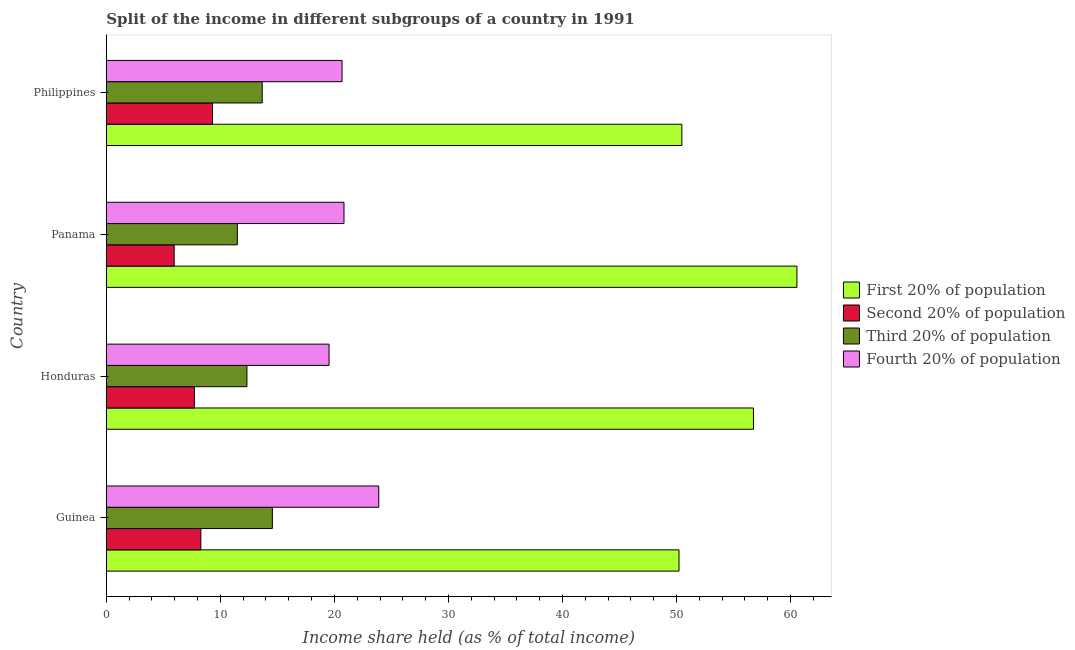Are the number of bars on each tick of the Y-axis equal?
Make the answer very short. Yes. How many bars are there on the 1st tick from the top?
Your answer should be very brief. 4. What is the share of the income held by first 20% of the population in Panama?
Ensure brevity in your answer.  60.56. Across all countries, what is the maximum share of the income held by second 20% of the population?
Your answer should be compact. 9.31. Across all countries, what is the minimum share of the income held by third 20% of the population?
Give a very brief answer. 11.49. In which country was the share of the income held by third 20% of the population maximum?
Keep it short and to the point. Guinea. In which country was the share of the income held by first 20% of the population minimum?
Make the answer very short. Guinea. What is the total share of the income held by first 20% of the population in the graph?
Your answer should be very brief. 218. What is the difference between the share of the income held by first 20% of the population in Panama and that in Philippines?
Your response must be concise. 10.09. What is the difference between the share of the income held by second 20% of the population in Philippines and the share of the income held by first 20% of the population in Guinea?
Give a very brief answer. -40.91. What is the average share of the income held by first 20% of the population per country?
Provide a succinct answer. 54.5. What is the difference between the share of the income held by third 20% of the population and share of the income held by second 20% of the population in Guinea?
Your answer should be compact. 6.27. In how many countries, is the share of the income held by third 20% of the population greater than 12 %?
Your answer should be very brief. 3. What is the ratio of the share of the income held by third 20% of the population in Honduras to that in Philippines?
Provide a succinct answer. 0.9. What is the difference between the highest and the lowest share of the income held by third 20% of the population?
Give a very brief answer. 3.07. In how many countries, is the share of the income held by second 20% of the population greater than the average share of the income held by second 20% of the population taken over all countries?
Offer a terse response. 2. Is the sum of the share of the income held by second 20% of the population in Guinea and Philippines greater than the maximum share of the income held by first 20% of the population across all countries?
Provide a succinct answer. No. Is it the case that in every country, the sum of the share of the income held by second 20% of the population and share of the income held by first 20% of the population is greater than the sum of share of the income held by third 20% of the population and share of the income held by fourth 20% of the population?
Make the answer very short. Yes. What does the 2nd bar from the top in Guinea represents?
Ensure brevity in your answer.  Third 20% of population. What does the 4th bar from the bottom in Honduras represents?
Provide a succinct answer. Fourth 20% of population. Is it the case that in every country, the sum of the share of the income held by first 20% of the population and share of the income held by second 20% of the population is greater than the share of the income held by third 20% of the population?
Offer a very short reply. Yes. How many bars are there?
Ensure brevity in your answer.  16. Does the graph contain grids?
Offer a terse response. No. Where does the legend appear in the graph?
Provide a short and direct response. Center right. What is the title of the graph?
Offer a terse response. Split of the income in different subgroups of a country in 1991. Does "Natural Gas" appear as one of the legend labels in the graph?
Provide a short and direct response. No. What is the label or title of the X-axis?
Provide a succinct answer. Income share held (as % of total income). What is the label or title of the Y-axis?
Your answer should be compact. Country. What is the Income share held (as % of total income) of First 20% of population in Guinea?
Your response must be concise. 50.22. What is the Income share held (as % of total income) of Second 20% of population in Guinea?
Make the answer very short. 8.29. What is the Income share held (as % of total income) in Third 20% of population in Guinea?
Your response must be concise. 14.56. What is the Income share held (as % of total income) of Fourth 20% of population in Guinea?
Provide a succinct answer. 23.89. What is the Income share held (as % of total income) in First 20% of population in Honduras?
Keep it short and to the point. 56.75. What is the Income share held (as % of total income) of Second 20% of population in Honduras?
Provide a short and direct response. 7.72. What is the Income share held (as % of total income) in Third 20% of population in Honduras?
Give a very brief answer. 12.33. What is the Income share held (as % of total income) in Fourth 20% of population in Honduras?
Ensure brevity in your answer.  19.53. What is the Income share held (as % of total income) in First 20% of population in Panama?
Provide a short and direct response. 60.56. What is the Income share held (as % of total income) in Second 20% of population in Panama?
Offer a very short reply. 5.95. What is the Income share held (as % of total income) of Third 20% of population in Panama?
Your response must be concise. 11.49. What is the Income share held (as % of total income) of Fourth 20% of population in Panama?
Offer a very short reply. 20.84. What is the Income share held (as % of total income) in First 20% of population in Philippines?
Your response must be concise. 50.47. What is the Income share held (as % of total income) in Second 20% of population in Philippines?
Your answer should be very brief. 9.31. What is the Income share held (as % of total income) in Third 20% of population in Philippines?
Provide a succinct answer. 13.67. What is the Income share held (as % of total income) in Fourth 20% of population in Philippines?
Your response must be concise. 20.67. Across all countries, what is the maximum Income share held (as % of total income) in First 20% of population?
Give a very brief answer. 60.56. Across all countries, what is the maximum Income share held (as % of total income) of Second 20% of population?
Your answer should be very brief. 9.31. Across all countries, what is the maximum Income share held (as % of total income) of Third 20% of population?
Offer a terse response. 14.56. Across all countries, what is the maximum Income share held (as % of total income) of Fourth 20% of population?
Keep it short and to the point. 23.89. Across all countries, what is the minimum Income share held (as % of total income) of First 20% of population?
Your response must be concise. 50.22. Across all countries, what is the minimum Income share held (as % of total income) of Second 20% of population?
Ensure brevity in your answer.  5.95. Across all countries, what is the minimum Income share held (as % of total income) in Third 20% of population?
Make the answer very short. 11.49. Across all countries, what is the minimum Income share held (as % of total income) in Fourth 20% of population?
Make the answer very short. 19.53. What is the total Income share held (as % of total income) in First 20% of population in the graph?
Ensure brevity in your answer.  218. What is the total Income share held (as % of total income) of Second 20% of population in the graph?
Your answer should be compact. 31.27. What is the total Income share held (as % of total income) of Third 20% of population in the graph?
Offer a terse response. 52.05. What is the total Income share held (as % of total income) of Fourth 20% of population in the graph?
Keep it short and to the point. 84.93. What is the difference between the Income share held (as % of total income) of First 20% of population in Guinea and that in Honduras?
Your response must be concise. -6.53. What is the difference between the Income share held (as % of total income) in Second 20% of population in Guinea and that in Honduras?
Ensure brevity in your answer.  0.57. What is the difference between the Income share held (as % of total income) of Third 20% of population in Guinea and that in Honduras?
Your answer should be very brief. 2.23. What is the difference between the Income share held (as % of total income) in Fourth 20% of population in Guinea and that in Honduras?
Your response must be concise. 4.36. What is the difference between the Income share held (as % of total income) in First 20% of population in Guinea and that in Panama?
Your answer should be very brief. -10.34. What is the difference between the Income share held (as % of total income) in Second 20% of population in Guinea and that in Panama?
Give a very brief answer. 2.34. What is the difference between the Income share held (as % of total income) in Third 20% of population in Guinea and that in Panama?
Give a very brief answer. 3.07. What is the difference between the Income share held (as % of total income) in Fourth 20% of population in Guinea and that in Panama?
Provide a succinct answer. 3.05. What is the difference between the Income share held (as % of total income) of Second 20% of population in Guinea and that in Philippines?
Ensure brevity in your answer.  -1.02. What is the difference between the Income share held (as % of total income) of Third 20% of population in Guinea and that in Philippines?
Offer a very short reply. 0.89. What is the difference between the Income share held (as % of total income) of Fourth 20% of population in Guinea and that in Philippines?
Make the answer very short. 3.22. What is the difference between the Income share held (as % of total income) of First 20% of population in Honduras and that in Panama?
Ensure brevity in your answer.  -3.81. What is the difference between the Income share held (as % of total income) in Second 20% of population in Honduras and that in Panama?
Your answer should be compact. 1.77. What is the difference between the Income share held (as % of total income) in Third 20% of population in Honduras and that in Panama?
Offer a very short reply. 0.84. What is the difference between the Income share held (as % of total income) in Fourth 20% of population in Honduras and that in Panama?
Offer a very short reply. -1.31. What is the difference between the Income share held (as % of total income) in First 20% of population in Honduras and that in Philippines?
Your answer should be very brief. 6.28. What is the difference between the Income share held (as % of total income) of Second 20% of population in Honduras and that in Philippines?
Your answer should be very brief. -1.59. What is the difference between the Income share held (as % of total income) in Third 20% of population in Honduras and that in Philippines?
Your answer should be very brief. -1.34. What is the difference between the Income share held (as % of total income) of Fourth 20% of population in Honduras and that in Philippines?
Offer a terse response. -1.14. What is the difference between the Income share held (as % of total income) in First 20% of population in Panama and that in Philippines?
Give a very brief answer. 10.09. What is the difference between the Income share held (as % of total income) in Second 20% of population in Panama and that in Philippines?
Offer a very short reply. -3.36. What is the difference between the Income share held (as % of total income) in Third 20% of population in Panama and that in Philippines?
Your response must be concise. -2.18. What is the difference between the Income share held (as % of total income) in Fourth 20% of population in Panama and that in Philippines?
Provide a succinct answer. 0.17. What is the difference between the Income share held (as % of total income) of First 20% of population in Guinea and the Income share held (as % of total income) of Second 20% of population in Honduras?
Your response must be concise. 42.5. What is the difference between the Income share held (as % of total income) of First 20% of population in Guinea and the Income share held (as % of total income) of Third 20% of population in Honduras?
Make the answer very short. 37.89. What is the difference between the Income share held (as % of total income) of First 20% of population in Guinea and the Income share held (as % of total income) of Fourth 20% of population in Honduras?
Your response must be concise. 30.69. What is the difference between the Income share held (as % of total income) of Second 20% of population in Guinea and the Income share held (as % of total income) of Third 20% of population in Honduras?
Your answer should be compact. -4.04. What is the difference between the Income share held (as % of total income) in Second 20% of population in Guinea and the Income share held (as % of total income) in Fourth 20% of population in Honduras?
Ensure brevity in your answer.  -11.24. What is the difference between the Income share held (as % of total income) of Third 20% of population in Guinea and the Income share held (as % of total income) of Fourth 20% of population in Honduras?
Keep it short and to the point. -4.97. What is the difference between the Income share held (as % of total income) in First 20% of population in Guinea and the Income share held (as % of total income) in Second 20% of population in Panama?
Make the answer very short. 44.27. What is the difference between the Income share held (as % of total income) of First 20% of population in Guinea and the Income share held (as % of total income) of Third 20% of population in Panama?
Your response must be concise. 38.73. What is the difference between the Income share held (as % of total income) in First 20% of population in Guinea and the Income share held (as % of total income) in Fourth 20% of population in Panama?
Your answer should be compact. 29.38. What is the difference between the Income share held (as % of total income) in Second 20% of population in Guinea and the Income share held (as % of total income) in Fourth 20% of population in Panama?
Keep it short and to the point. -12.55. What is the difference between the Income share held (as % of total income) in Third 20% of population in Guinea and the Income share held (as % of total income) in Fourth 20% of population in Panama?
Give a very brief answer. -6.28. What is the difference between the Income share held (as % of total income) of First 20% of population in Guinea and the Income share held (as % of total income) of Second 20% of population in Philippines?
Keep it short and to the point. 40.91. What is the difference between the Income share held (as % of total income) of First 20% of population in Guinea and the Income share held (as % of total income) of Third 20% of population in Philippines?
Make the answer very short. 36.55. What is the difference between the Income share held (as % of total income) in First 20% of population in Guinea and the Income share held (as % of total income) in Fourth 20% of population in Philippines?
Offer a very short reply. 29.55. What is the difference between the Income share held (as % of total income) in Second 20% of population in Guinea and the Income share held (as % of total income) in Third 20% of population in Philippines?
Give a very brief answer. -5.38. What is the difference between the Income share held (as % of total income) of Second 20% of population in Guinea and the Income share held (as % of total income) of Fourth 20% of population in Philippines?
Ensure brevity in your answer.  -12.38. What is the difference between the Income share held (as % of total income) in Third 20% of population in Guinea and the Income share held (as % of total income) in Fourth 20% of population in Philippines?
Keep it short and to the point. -6.11. What is the difference between the Income share held (as % of total income) in First 20% of population in Honduras and the Income share held (as % of total income) in Second 20% of population in Panama?
Your answer should be compact. 50.8. What is the difference between the Income share held (as % of total income) of First 20% of population in Honduras and the Income share held (as % of total income) of Third 20% of population in Panama?
Provide a succinct answer. 45.26. What is the difference between the Income share held (as % of total income) of First 20% of population in Honduras and the Income share held (as % of total income) of Fourth 20% of population in Panama?
Your response must be concise. 35.91. What is the difference between the Income share held (as % of total income) of Second 20% of population in Honduras and the Income share held (as % of total income) of Third 20% of population in Panama?
Your response must be concise. -3.77. What is the difference between the Income share held (as % of total income) of Second 20% of population in Honduras and the Income share held (as % of total income) of Fourth 20% of population in Panama?
Give a very brief answer. -13.12. What is the difference between the Income share held (as % of total income) of Third 20% of population in Honduras and the Income share held (as % of total income) of Fourth 20% of population in Panama?
Offer a very short reply. -8.51. What is the difference between the Income share held (as % of total income) in First 20% of population in Honduras and the Income share held (as % of total income) in Second 20% of population in Philippines?
Give a very brief answer. 47.44. What is the difference between the Income share held (as % of total income) in First 20% of population in Honduras and the Income share held (as % of total income) in Third 20% of population in Philippines?
Make the answer very short. 43.08. What is the difference between the Income share held (as % of total income) of First 20% of population in Honduras and the Income share held (as % of total income) of Fourth 20% of population in Philippines?
Offer a terse response. 36.08. What is the difference between the Income share held (as % of total income) of Second 20% of population in Honduras and the Income share held (as % of total income) of Third 20% of population in Philippines?
Provide a short and direct response. -5.95. What is the difference between the Income share held (as % of total income) in Second 20% of population in Honduras and the Income share held (as % of total income) in Fourth 20% of population in Philippines?
Ensure brevity in your answer.  -12.95. What is the difference between the Income share held (as % of total income) of Third 20% of population in Honduras and the Income share held (as % of total income) of Fourth 20% of population in Philippines?
Keep it short and to the point. -8.34. What is the difference between the Income share held (as % of total income) of First 20% of population in Panama and the Income share held (as % of total income) of Second 20% of population in Philippines?
Your response must be concise. 51.25. What is the difference between the Income share held (as % of total income) of First 20% of population in Panama and the Income share held (as % of total income) of Third 20% of population in Philippines?
Offer a very short reply. 46.89. What is the difference between the Income share held (as % of total income) in First 20% of population in Panama and the Income share held (as % of total income) in Fourth 20% of population in Philippines?
Offer a terse response. 39.89. What is the difference between the Income share held (as % of total income) in Second 20% of population in Panama and the Income share held (as % of total income) in Third 20% of population in Philippines?
Give a very brief answer. -7.72. What is the difference between the Income share held (as % of total income) in Second 20% of population in Panama and the Income share held (as % of total income) in Fourth 20% of population in Philippines?
Keep it short and to the point. -14.72. What is the difference between the Income share held (as % of total income) in Third 20% of population in Panama and the Income share held (as % of total income) in Fourth 20% of population in Philippines?
Offer a terse response. -9.18. What is the average Income share held (as % of total income) in First 20% of population per country?
Provide a short and direct response. 54.5. What is the average Income share held (as % of total income) in Second 20% of population per country?
Provide a short and direct response. 7.82. What is the average Income share held (as % of total income) in Third 20% of population per country?
Your answer should be compact. 13.01. What is the average Income share held (as % of total income) of Fourth 20% of population per country?
Provide a short and direct response. 21.23. What is the difference between the Income share held (as % of total income) in First 20% of population and Income share held (as % of total income) in Second 20% of population in Guinea?
Offer a very short reply. 41.93. What is the difference between the Income share held (as % of total income) in First 20% of population and Income share held (as % of total income) in Third 20% of population in Guinea?
Offer a terse response. 35.66. What is the difference between the Income share held (as % of total income) of First 20% of population and Income share held (as % of total income) of Fourth 20% of population in Guinea?
Your answer should be very brief. 26.33. What is the difference between the Income share held (as % of total income) of Second 20% of population and Income share held (as % of total income) of Third 20% of population in Guinea?
Your response must be concise. -6.27. What is the difference between the Income share held (as % of total income) in Second 20% of population and Income share held (as % of total income) in Fourth 20% of population in Guinea?
Give a very brief answer. -15.6. What is the difference between the Income share held (as % of total income) in Third 20% of population and Income share held (as % of total income) in Fourth 20% of population in Guinea?
Your answer should be compact. -9.33. What is the difference between the Income share held (as % of total income) in First 20% of population and Income share held (as % of total income) in Second 20% of population in Honduras?
Your answer should be compact. 49.03. What is the difference between the Income share held (as % of total income) of First 20% of population and Income share held (as % of total income) of Third 20% of population in Honduras?
Make the answer very short. 44.42. What is the difference between the Income share held (as % of total income) in First 20% of population and Income share held (as % of total income) in Fourth 20% of population in Honduras?
Offer a very short reply. 37.22. What is the difference between the Income share held (as % of total income) in Second 20% of population and Income share held (as % of total income) in Third 20% of population in Honduras?
Make the answer very short. -4.61. What is the difference between the Income share held (as % of total income) in Second 20% of population and Income share held (as % of total income) in Fourth 20% of population in Honduras?
Your answer should be very brief. -11.81. What is the difference between the Income share held (as % of total income) in First 20% of population and Income share held (as % of total income) in Second 20% of population in Panama?
Offer a very short reply. 54.61. What is the difference between the Income share held (as % of total income) in First 20% of population and Income share held (as % of total income) in Third 20% of population in Panama?
Offer a terse response. 49.07. What is the difference between the Income share held (as % of total income) in First 20% of population and Income share held (as % of total income) in Fourth 20% of population in Panama?
Your response must be concise. 39.72. What is the difference between the Income share held (as % of total income) of Second 20% of population and Income share held (as % of total income) of Third 20% of population in Panama?
Keep it short and to the point. -5.54. What is the difference between the Income share held (as % of total income) of Second 20% of population and Income share held (as % of total income) of Fourth 20% of population in Panama?
Give a very brief answer. -14.89. What is the difference between the Income share held (as % of total income) in Third 20% of population and Income share held (as % of total income) in Fourth 20% of population in Panama?
Provide a succinct answer. -9.35. What is the difference between the Income share held (as % of total income) in First 20% of population and Income share held (as % of total income) in Second 20% of population in Philippines?
Make the answer very short. 41.16. What is the difference between the Income share held (as % of total income) in First 20% of population and Income share held (as % of total income) in Third 20% of population in Philippines?
Offer a terse response. 36.8. What is the difference between the Income share held (as % of total income) in First 20% of population and Income share held (as % of total income) in Fourth 20% of population in Philippines?
Your answer should be very brief. 29.8. What is the difference between the Income share held (as % of total income) of Second 20% of population and Income share held (as % of total income) of Third 20% of population in Philippines?
Provide a short and direct response. -4.36. What is the difference between the Income share held (as % of total income) in Second 20% of population and Income share held (as % of total income) in Fourth 20% of population in Philippines?
Offer a very short reply. -11.36. What is the ratio of the Income share held (as % of total income) of First 20% of population in Guinea to that in Honduras?
Offer a very short reply. 0.88. What is the ratio of the Income share held (as % of total income) in Second 20% of population in Guinea to that in Honduras?
Your answer should be compact. 1.07. What is the ratio of the Income share held (as % of total income) of Third 20% of population in Guinea to that in Honduras?
Ensure brevity in your answer.  1.18. What is the ratio of the Income share held (as % of total income) of Fourth 20% of population in Guinea to that in Honduras?
Offer a terse response. 1.22. What is the ratio of the Income share held (as % of total income) in First 20% of population in Guinea to that in Panama?
Provide a short and direct response. 0.83. What is the ratio of the Income share held (as % of total income) of Second 20% of population in Guinea to that in Panama?
Give a very brief answer. 1.39. What is the ratio of the Income share held (as % of total income) in Third 20% of population in Guinea to that in Panama?
Give a very brief answer. 1.27. What is the ratio of the Income share held (as % of total income) of Fourth 20% of population in Guinea to that in Panama?
Offer a terse response. 1.15. What is the ratio of the Income share held (as % of total income) of First 20% of population in Guinea to that in Philippines?
Give a very brief answer. 0.99. What is the ratio of the Income share held (as % of total income) of Second 20% of population in Guinea to that in Philippines?
Give a very brief answer. 0.89. What is the ratio of the Income share held (as % of total income) in Third 20% of population in Guinea to that in Philippines?
Make the answer very short. 1.07. What is the ratio of the Income share held (as % of total income) of Fourth 20% of population in Guinea to that in Philippines?
Keep it short and to the point. 1.16. What is the ratio of the Income share held (as % of total income) of First 20% of population in Honduras to that in Panama?
Give a very brief answer. 0.94. What is the ratio of the Income share held (as % of total income) in Second 20% of population in Honduras to that in Panama?
Your answer should be compact. 1.3. What is the ratio of the Income share held (as % of total income) of Third 20% of population in Honduras to that in Panama?
Make the answer very short. 1.07. What is the ratio of the Income share held (as % of total income) of Fourth 20% of population in Honduras to that in Panama?
Offer a very short reply. 0.94. What is the ratio of the Income share held (as % of total income) in First 20% of population in Honduras to that in Philippines?
Provide a short and direct response. 1.12. What is the ratio of the Income share held (as % of total income) of Second 20% of population in Honduras to that in Philippines?
Keep it short and to the point. 0.83. What is the ratio of the Income share held (as % of total income) of Third 20% of population in Honduras to that in Philippines?
Offer a very short reply. 0.9. What is the ratio of the Income share held (as % of total income) of Fourth 20% of population in Honduras to that in Philippines?
Provide a succinct answer. 0.94. What is the ratio of the Income share held (as % of total income) of First 20% of population in Panama to that in Philippines?
Your response must be concise. 1.2. What is the ratio of the Income share held (as % of total income) of Second 20% of population in Panama to that in Philippines?
Ensure brevity in your answer.  0.64. What is the ratio of the Income share held (as % of total income) of Third 20% of population in Panama to that in Philippines?
Make the answer very short. 0.84. What is the ratio of the Income share held (as % of total income) in Fourth 20% of population in Panama to that in Philippines?
Make the answer very short. 1.01. What is the difference between the highest and the second highest Income share held (as % of total income) of First 20% of population?
Your answer should be compact. 3.81. What is the difference between the highest and the second highest Income share held (as % of total income) in Third 20% of population?
Make the answer very short. 0.89. What is the difference between the highest and the second highest Income share held (as % of total income) in Fourth 20% of population?
Keep it short and to the point. 3.05. What is the difference between the highest and the lowest Income share held (as % of total income) of First 20% of population?
Offer a terse response. 10.34. What is the difference between the highest and the lowest Income share held (as % of total income) in Second 20% of population?
Offer a very short reply. 3.36. What is the difference between the highest and the lowest Income share held (as % of total income) in Third 20% of population?
Your answer should be compact. 3.07. What is the difference between the highest and the lowest Income share held (as % of total income) in Fourth 20% of population?
Make the answer very short. 4.36. 